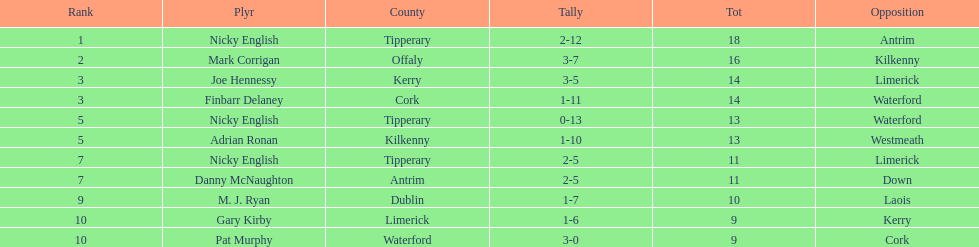What is the smallest total amount on the list? 9. 